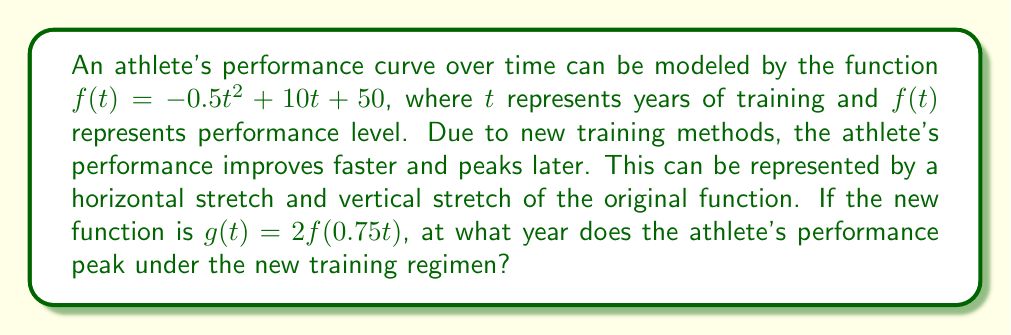Solve this math problem. 1) First, let's understand what $g(t) = 2f(0.75t)$ means:
   - The factor 0.75 inside the function represents a horizontal stretch by a factor of 4/3.
   - The factor 2 outside the function represents a vertical stretch by a factor of 2.

2) To find the peak of $g(t)$, we need to find its maximum point. This occurs where the derivative $g'(t) = 0$.

3) Let's derive $g(t)$:
   $g(t) = 2f(0.75t) = 2(-0.5(0.75t)^2 + 10(0.75t) + 50)$
   $g(t) = 2(-0.28125t^2 + 7.5t + 50)$
   $g(t) = -0.5625t^2 + 15t + 100$

4) Now, let's find $g'(t)$:
   $g'(t) = -1.125t + 15$

5) Set $g'(t) = 0$ and solve for $t$:
   $-1.125t + 15 = 0$
   $-1.125t = -15$
   $t = \frac{-15}{-1.125} = \frac{40}{3} \approx 13.33$

6) This $t$ value represents the number of years at which the athlete's performance peaks under the new training regimen.
Answer: $\frac{40}{3}$ years 